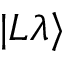Convert formula to latex. <formula><loc_0><loc_0><loc_500><loc_500>| L \lambda \rangle</formula> 